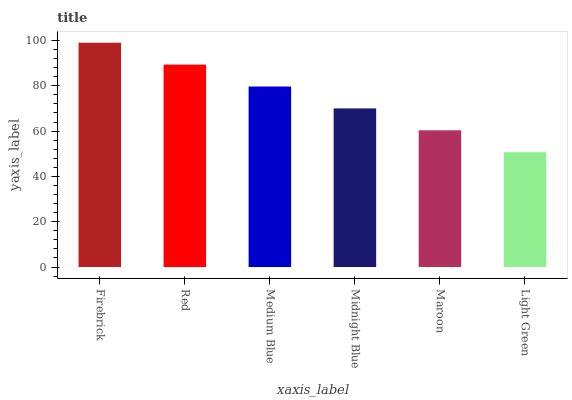Is Light Green the minimum?
Answer yes or no. Yes. Is Firebrick the maximum?
Answer yes or no. Yes. Is Red the minimum?
Answer yes or no. No. Is Red the maximum?
Answer yes or no. No. Is Firebrick greater than Red?
Answer yes or no. Yes. Is Red less than Firebrick?
Answer yes or no. Yes. Is Red greater than Firebrick?
Answer yes or no. No. Is Firebrick less than Red?
Answer yes or no. No. Is Medium Blue the high median?
Answer yes or no. Yes. Is Midnight Blue the low median?
Answer yes or no. Yes. Is Red the high median?
Answer yes or no. No. Is Maroon the low median?
Answer yes or no. No. 